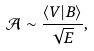<formula> <loc_0><loc_0><loc_500><loc_500>\mathcal { A } \sim \frac { \langle V | B \rangle } { \sqrt { E } } ,</formula> 